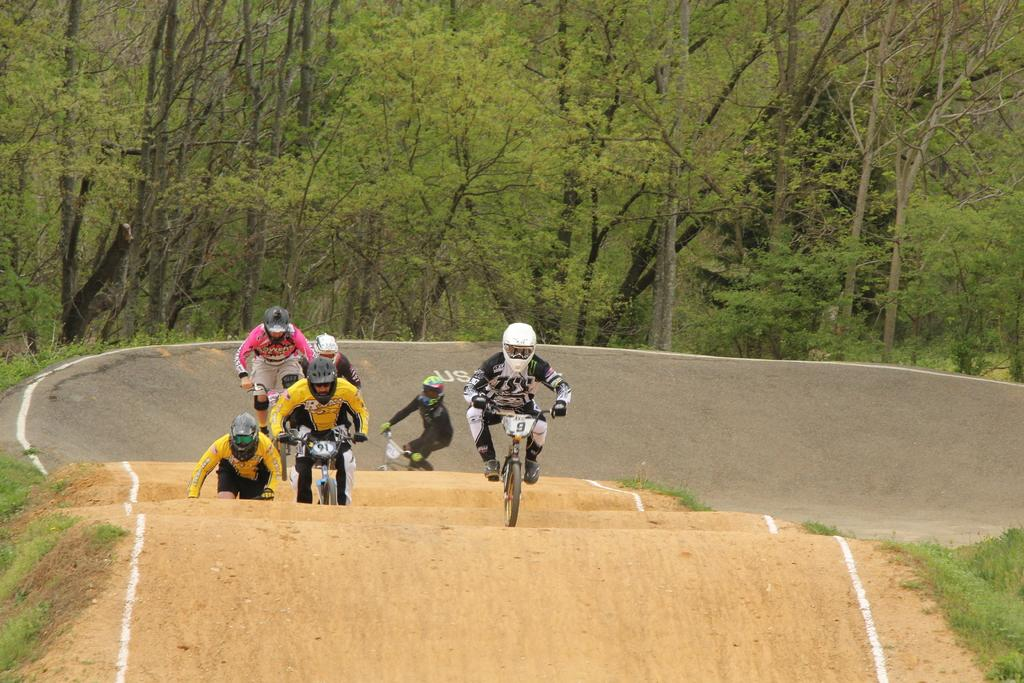Who or what can be seen in the image? There are people in the image. What are the people doing in the image? The people are riding bicycles. What safety precaution are the people taking while riding their bicycles? The people are wearing helmets. What activity are the people engaged in with their bicycles? The people are racing with their bicycles. What can be seen in the distance in the image? There are trees in the background of the image. What type of property can be seen in the image? There is no property visible in the image; it features people riding bicycles and racing. What sound do the bells make in the image? There are no bells present in the image. 